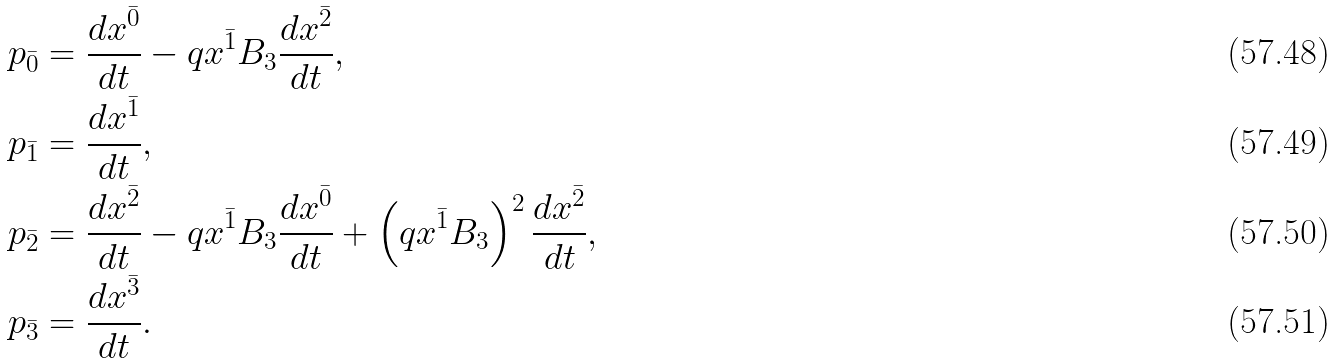<formula> <loc_0><loc_0><loc_500><loc_500>& p _ { \bar { 0 } } = \frac { d x ^ { \bar { 0 } } } { d t } - q x ^ { \bar { 1 } } B _ { 3 } \frac { d x ^ { \bar { 2 } } } { d t } , \\ & p _ { \bar { 1 } } = \frac { d x ^ { \bar { 1 } } } { d t } , \\ & p _ { \bar { 2 } } = \frac { d x ^ { \bar { 2 } } } { d t } - q x ^ { \bar { 1 } } B _ { 3 } \frac { d x ^ { \bar { 0 } } } { d t } + \left ( q x ^ { \bar { 1 } } B _ { 3 } \right ) ^ { 2 } \frac { d x ^ { \bar { 2 } } } { d t } , \\ & p _ { \bar { 3 } } = \frac { d x ^ { \bar { 3 } } } { d t } .</formula> 